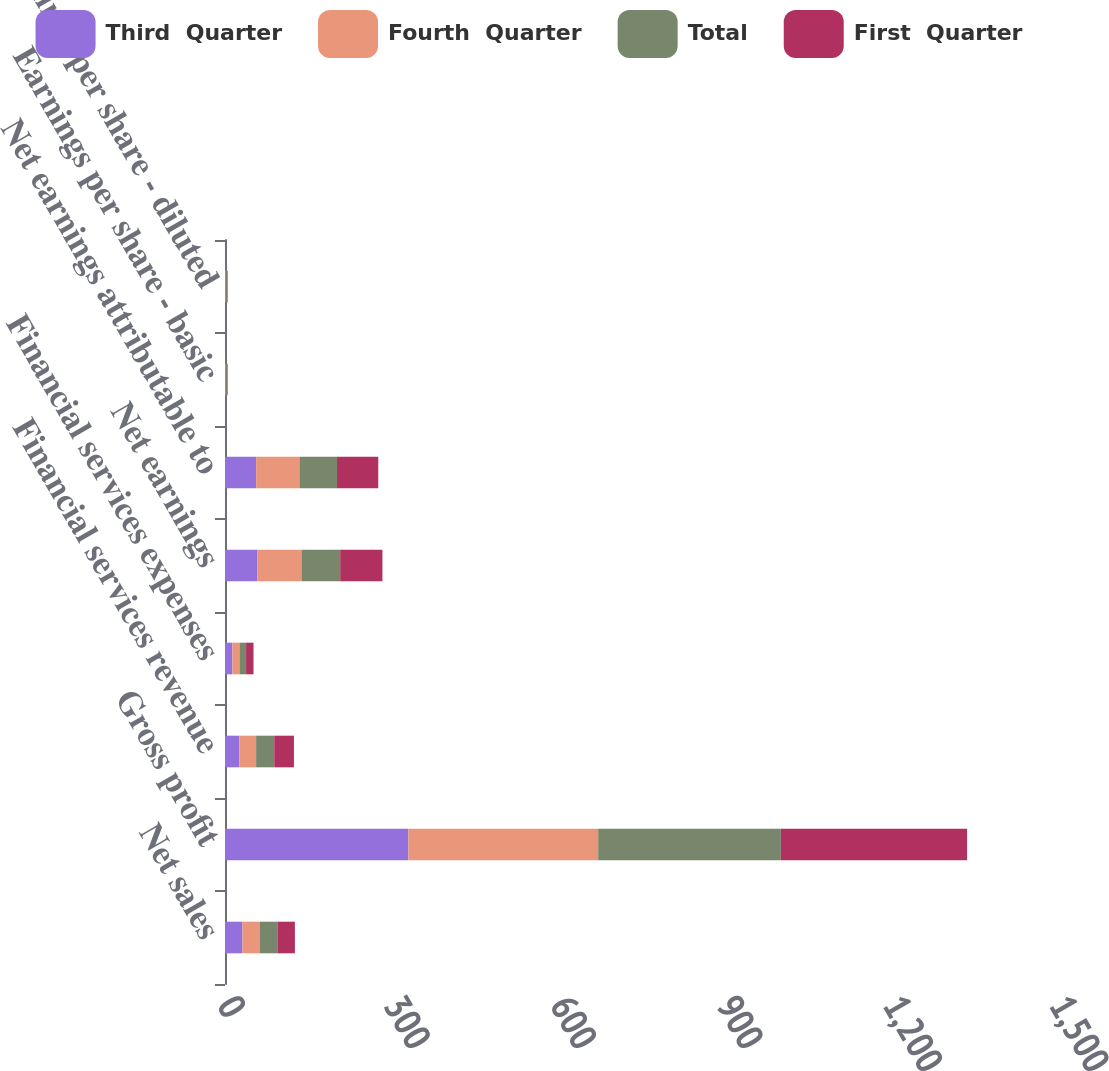Convert chart to OTSL. <chart><loc_0><loc_0><loc_500><loc_500><stacked_bar_chart><ecel><fcel>Net sales<fcel>Gross profit<fcel>Financial services revenue<fcel>Financial services expenses<fcel>Net earnings<fcel>Net earnings attributable to<fcel>Earnings per share - basic<fcel>Earnings per share - diluted<nl><fcel>Third  Quarter<fcel>31.5<fcel>330.6<fcel>25.8<fcel>13.3<fcel>58<fcel>56.2<fcel>0.97<fcel>0.96<nl><fcel>Fourth  Quarter<fcel>31.5<fcel>342.2<fcel>30.3<fcel>12.8<fcel>79.9<fcel>78<fcel>1.34<fcel>1.33<nl><fcel>Total<fcel>31.5<fcel>329.3<fcel>32.7<fcel>11.9<fcel>69.8<fcel>67.8<fcel>1.16<fcel>1.16<nl><fcel>First  Quarter<fcel>31.5<fcel>335.8<fcel>35.5<fcel>13.4<fcel>76.1<fcel>74.3<fcel>1.28<fcel>1.27<nl></chart> 